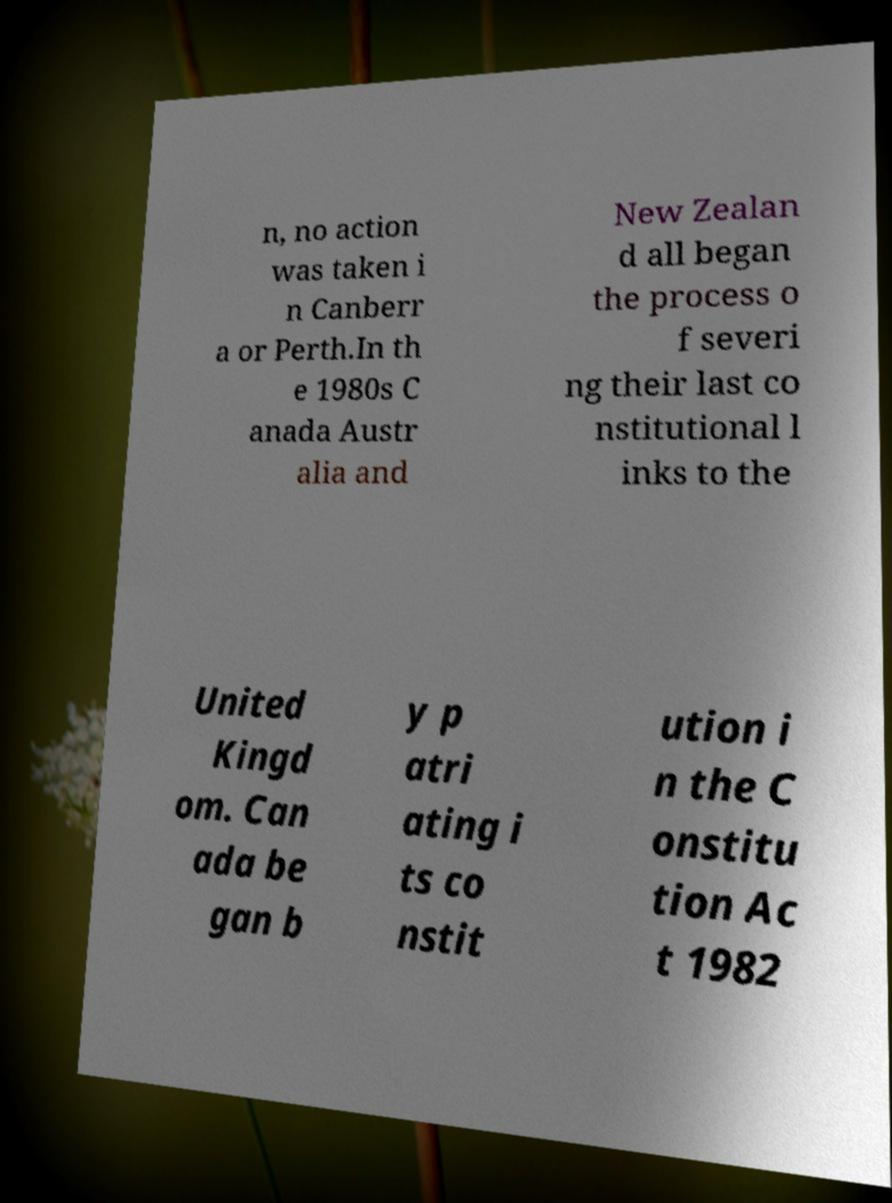Could you assist in decoding the text presented in this image and type it out clearly? n, no action was taken i n Canberr a or Perth.In th e 1980s C anada Austr alia and New Zealan d all began the process o f severi ng their last co nstitutional l inks to the United Kingd om. Can ada be gan b y p atri ating i ts co nstit ution i n the C onstitu tion Ac t 1982 